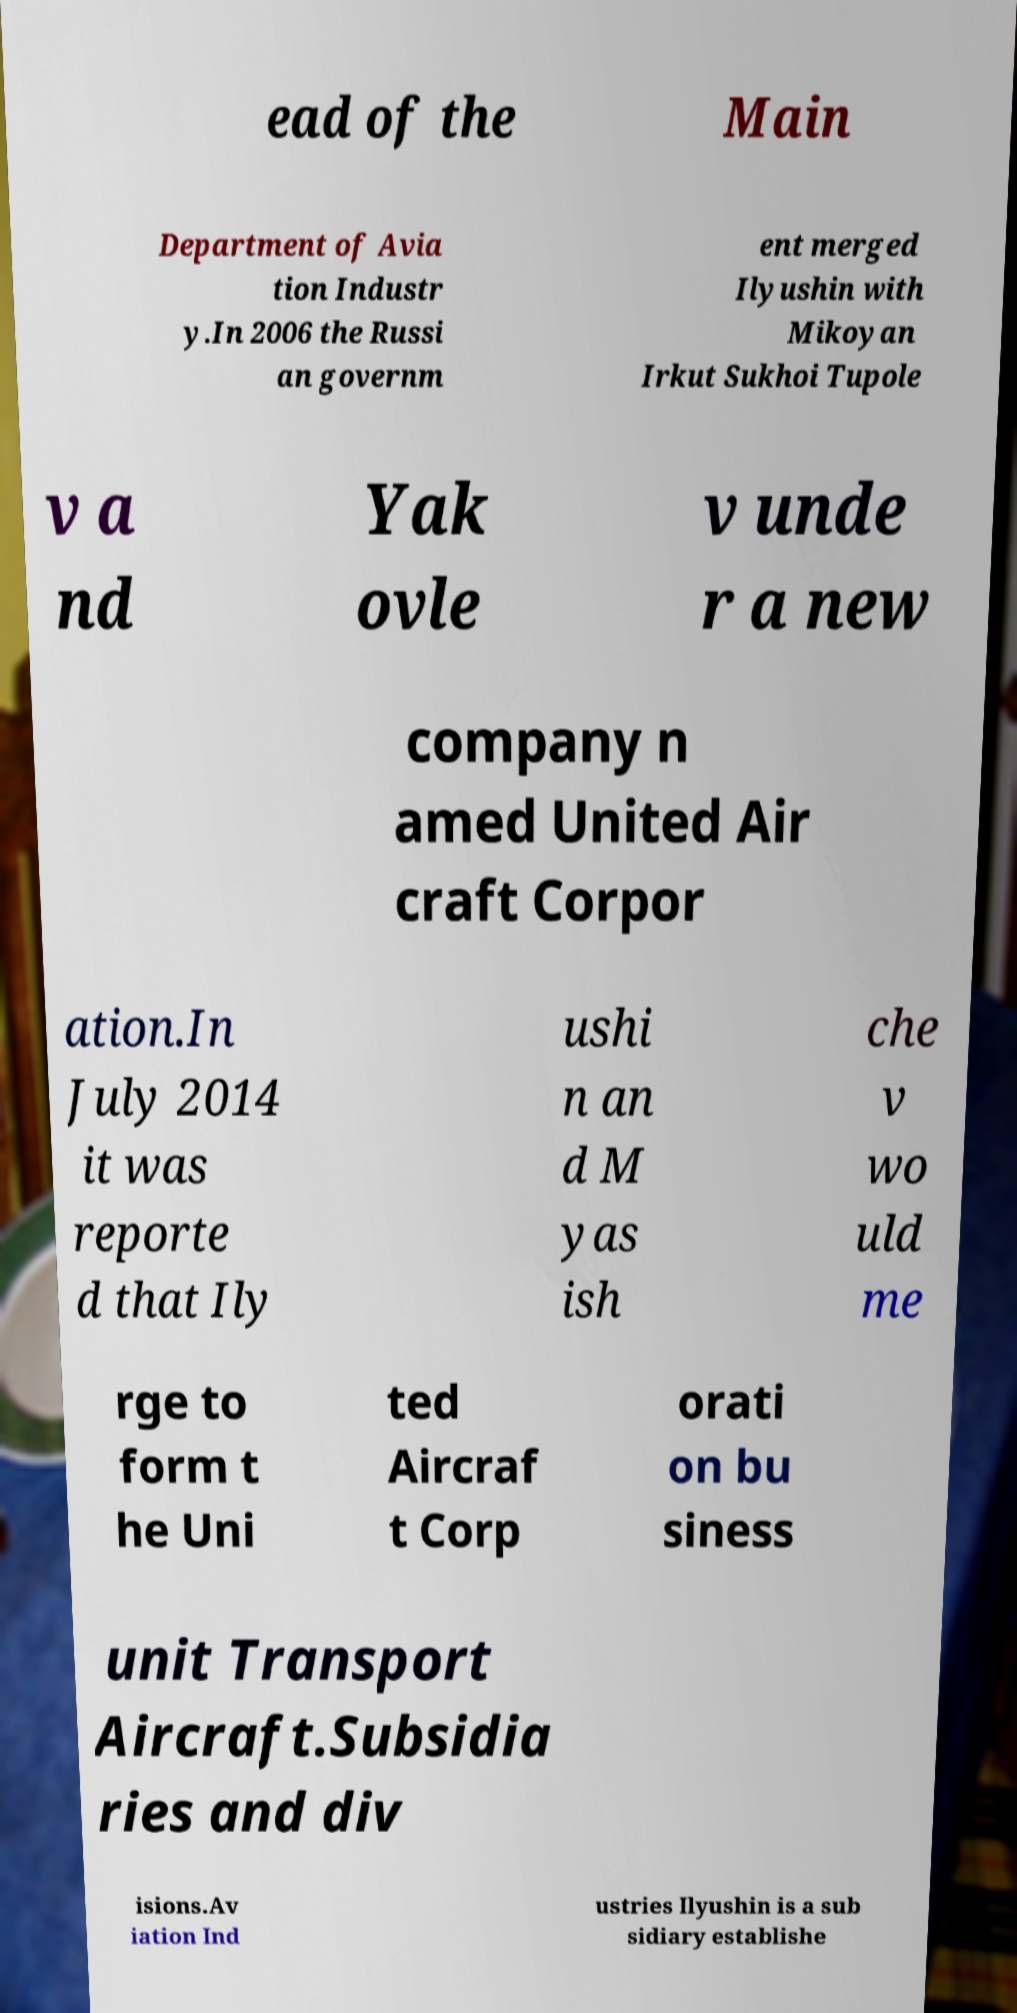There's text embedded in this image that I need extracted. Can you transcribe it verbatim? ead of the Main Department of Avia tion Industr y.In 2006 the Russi an governm ent merged Ilyushin with Mikoyan Irkut Sukhoi Tupole v a nd Yak ovle v unde r a new company n amed United Air craft Corpor ation.In July 2014 it was reporte d that Ily ushi n an d M yas ish che v wo uld me rge to form t he Uni ted Aircraf t Corp orati on bu siness unit Transport Aircraft.Subsidia ries and div isions.Av iation Ind ustries Ilyushin is a sub sidiary establishe 